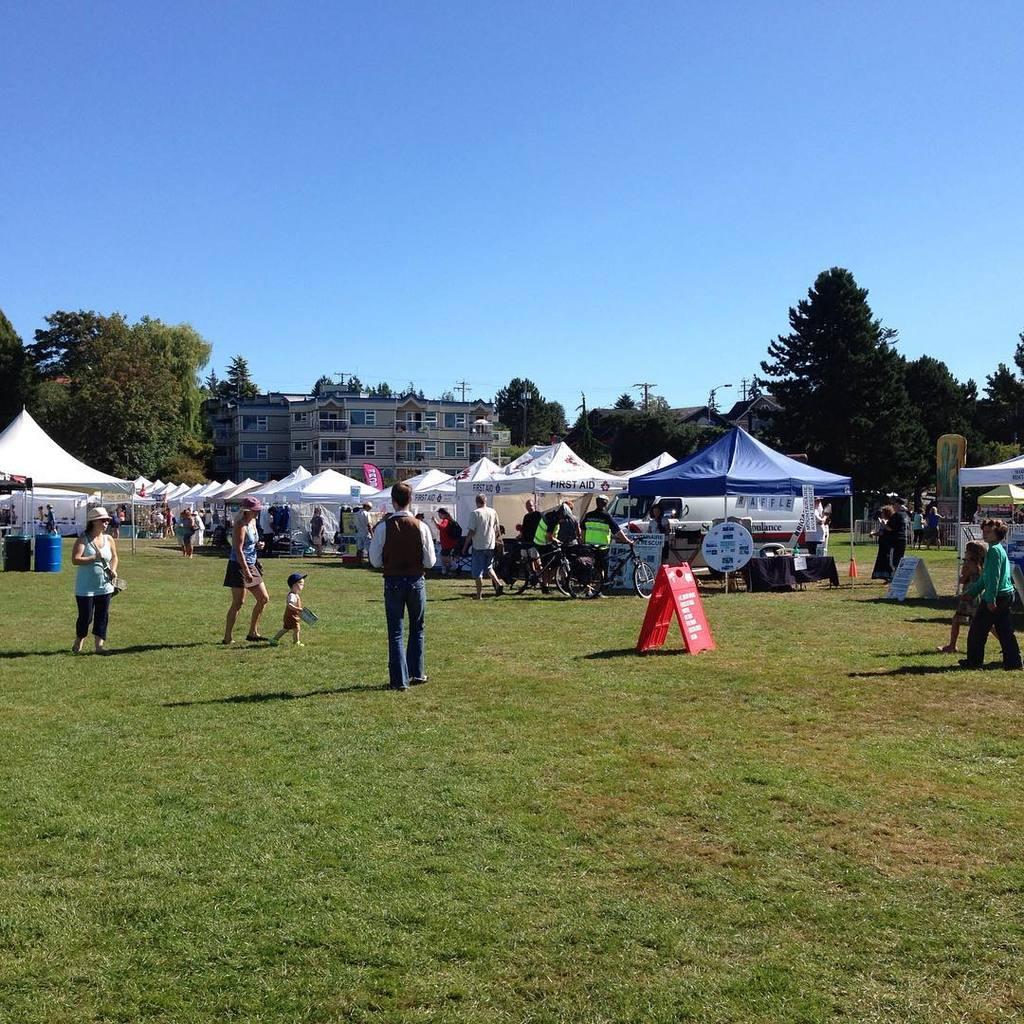In one or two sentences, can you explain what this image depicts? In this image we can see few persons on the grassy land. There are bicycle, tents and boards with text. Behind the persons we can see the buildings and a group of trees. At the top we can see the sky. 